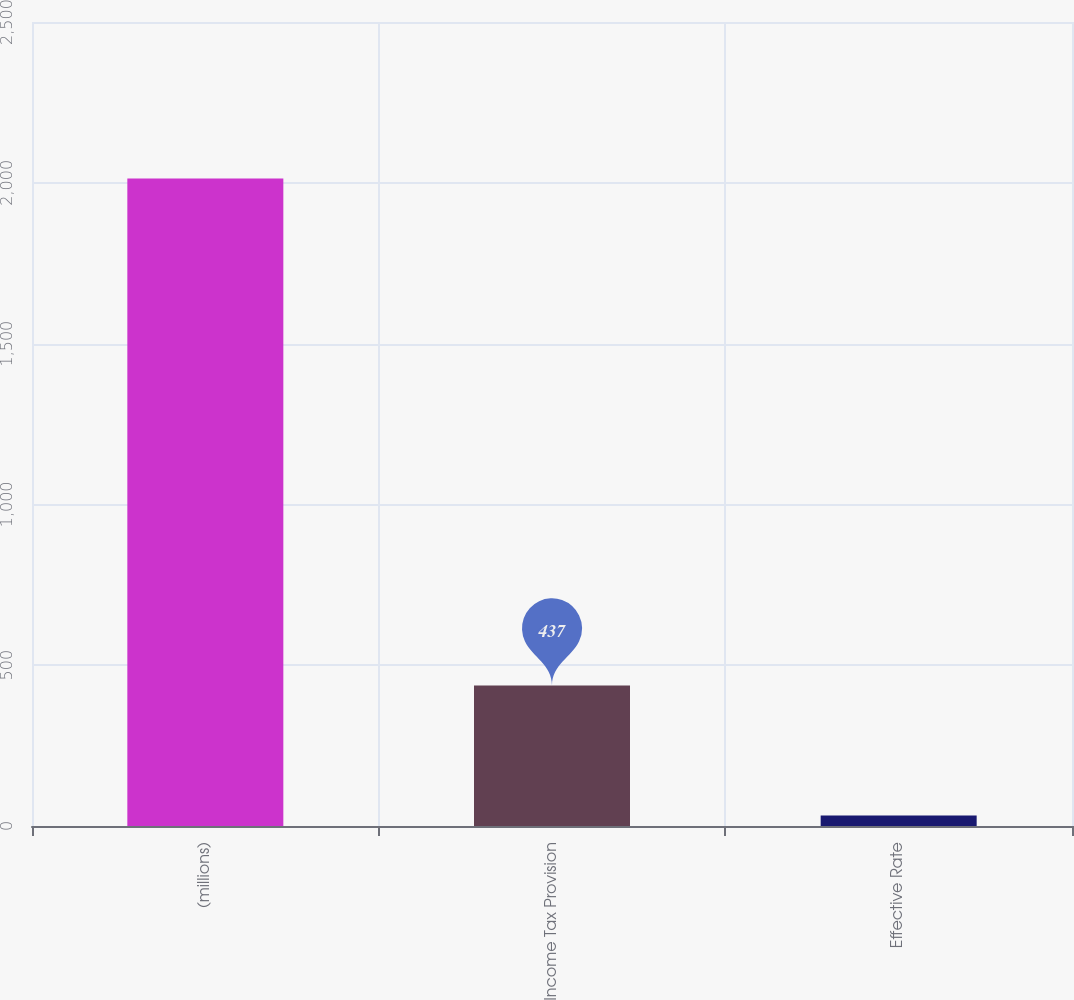Convert chart. <chart><loc_0><loc_0><loc_500><loc_500><bar_chart><fcel>(millions)<fcel>Income Tax Provision<fcel>Effective Rate<nl><fcel>2013<fcel>437<fcel>32.5<nl></chart> 